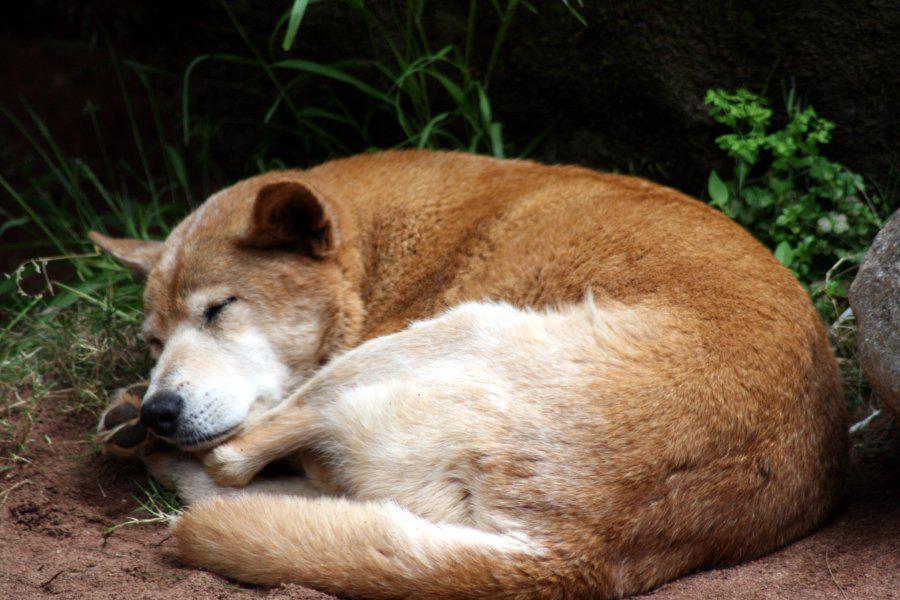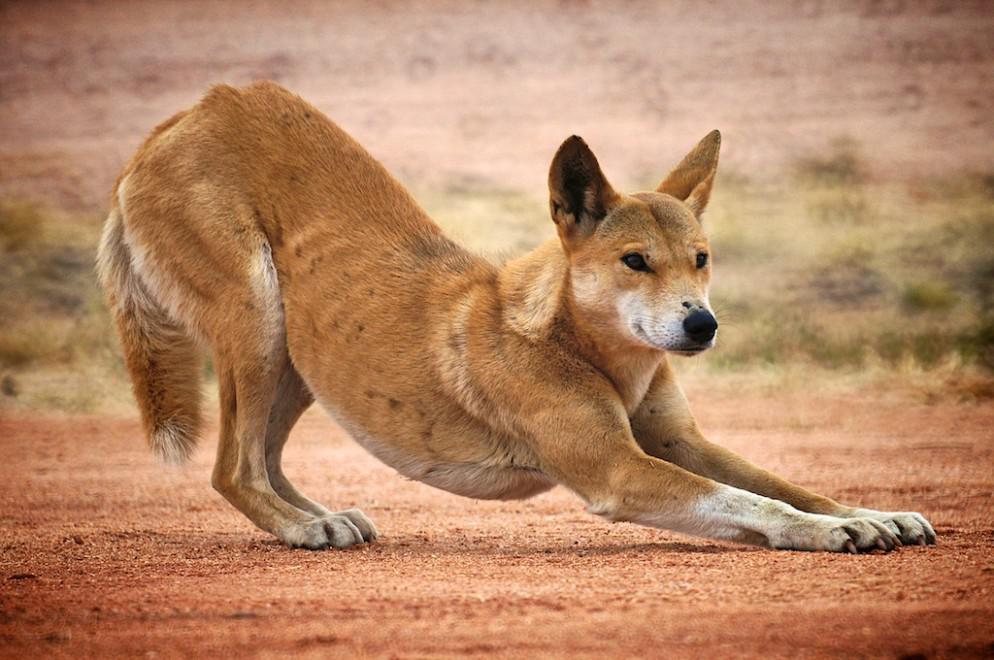The first image is the image on the left, the second image is the image on the right. For the images shown, is this caption "An image includes an adult dingo that is not lying with its head on the ground." true? Answer yes or no. Yes. The first image is the image on the left, the second image is the image on the right. For the images displayed, is the sentence "The left image contains exactly two wild dogs." factually correct? Answer yes or no. No. 